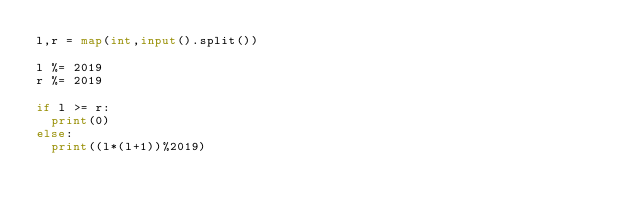Convert code to text. <code><loc_0><loc_0><loc_500><loc_500><_Python_>l,r = map(int,input().split())

l %= 2019
r %= 2019

if l >= r:
  print(0)
else:
  print((l*(l+1))%2019)
</code> 